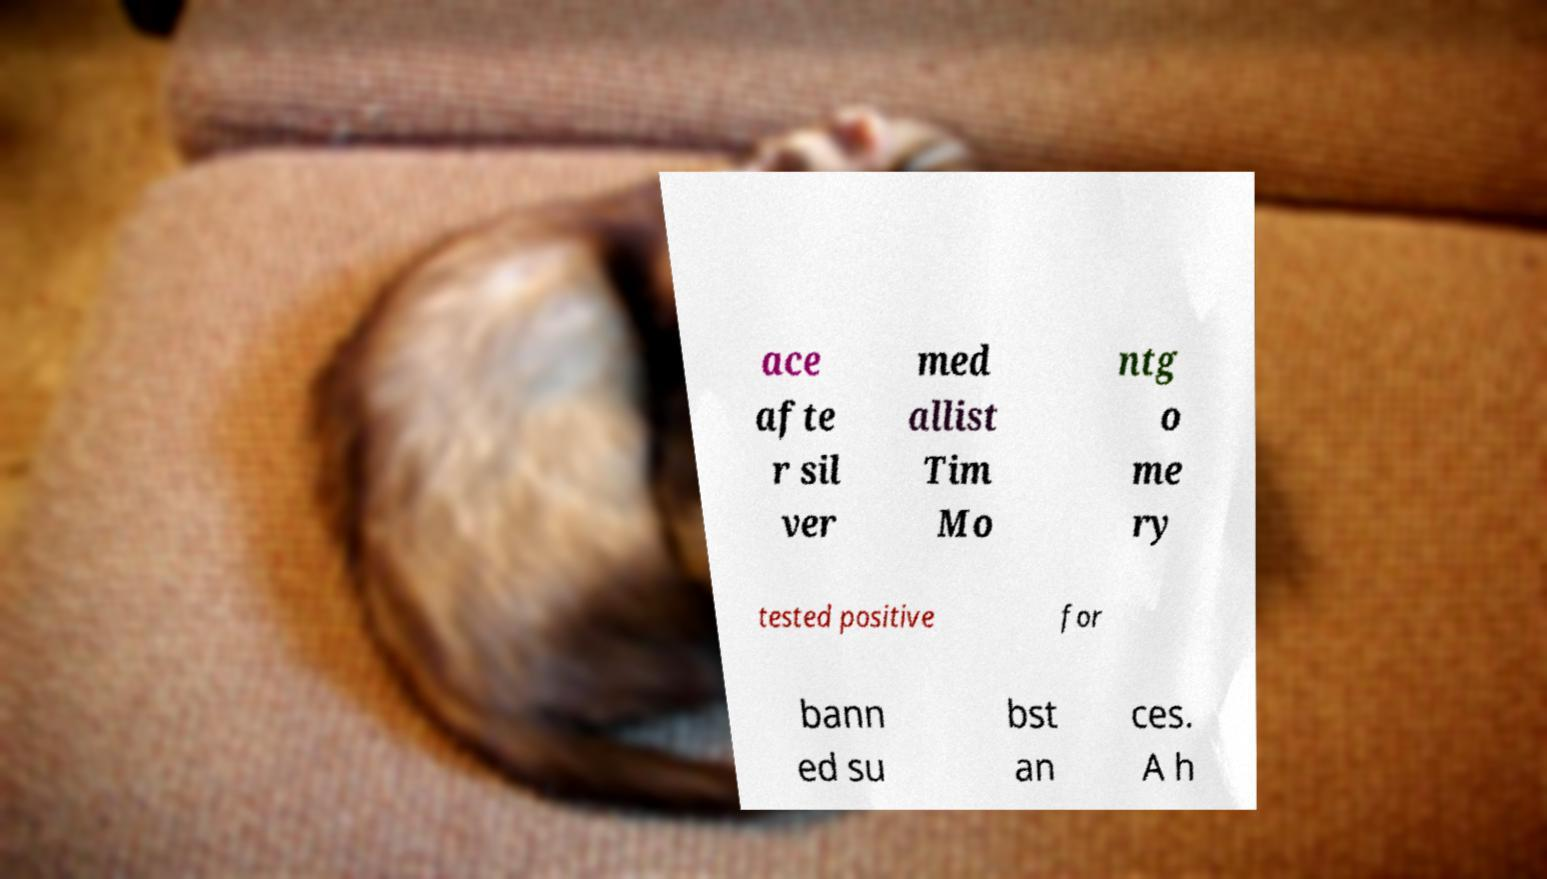Could you assist in decoding the text presented in this image and type it out clearly? ace afte r sil ver med allist Tim Mo ntg o me ry tested positive for bann ed su bst an ces. A h 